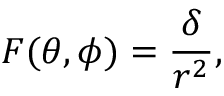<formula> <loc_0><loc_0><loc_500><loc_500>F ( \theta , \phi ) = \frac { \delta } { r ^ { 2 } } ,</formula> 